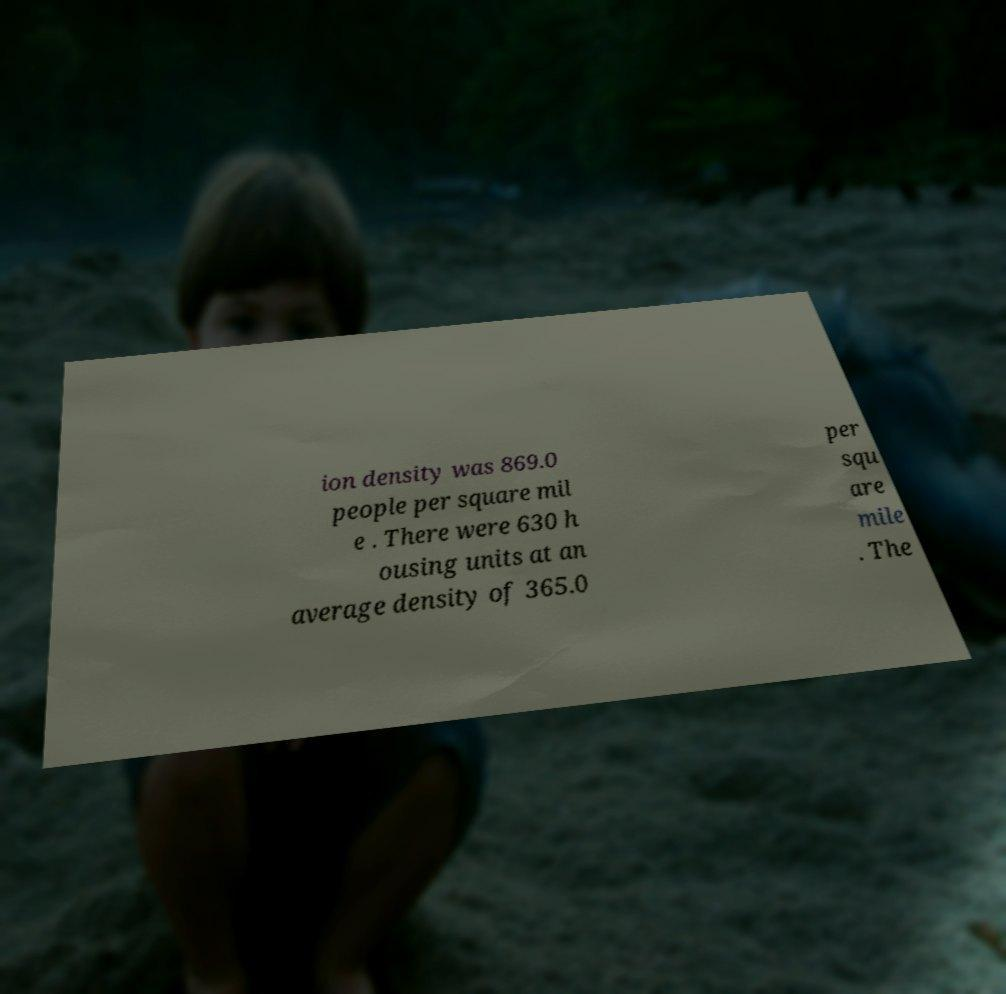I need the written content from this picture converted into text. Can you do that? ion density was 869.0 people per square mil e . There were 630 h ousing units at an average density of 365.0 per squ are mile . The 